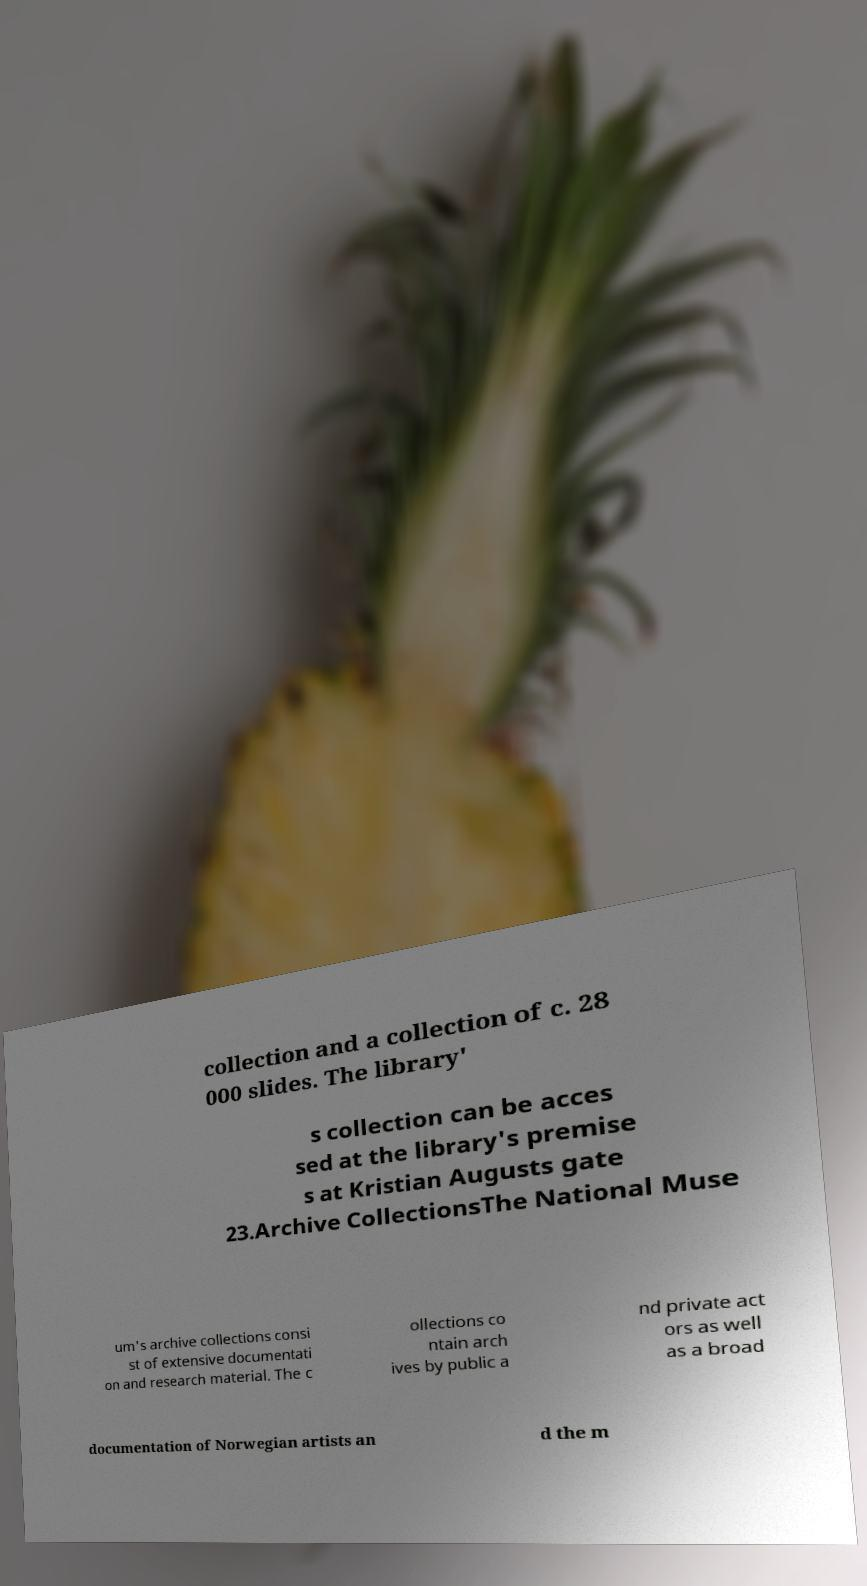Could you assist in decoding the text presented in this image and type it out clearly? collection and a collection of c. 28 000 slides. The library' s collection can be acces sed at the library's premise s at Kristian Augusts gate 23.Archive CollectionsThe National Muse um's archive collections consi st of extensive documentati on and research material. The c ollections co ntain arch ives by public a nd private act ors as well as a broad documentation of Norwegian artists an d the m 